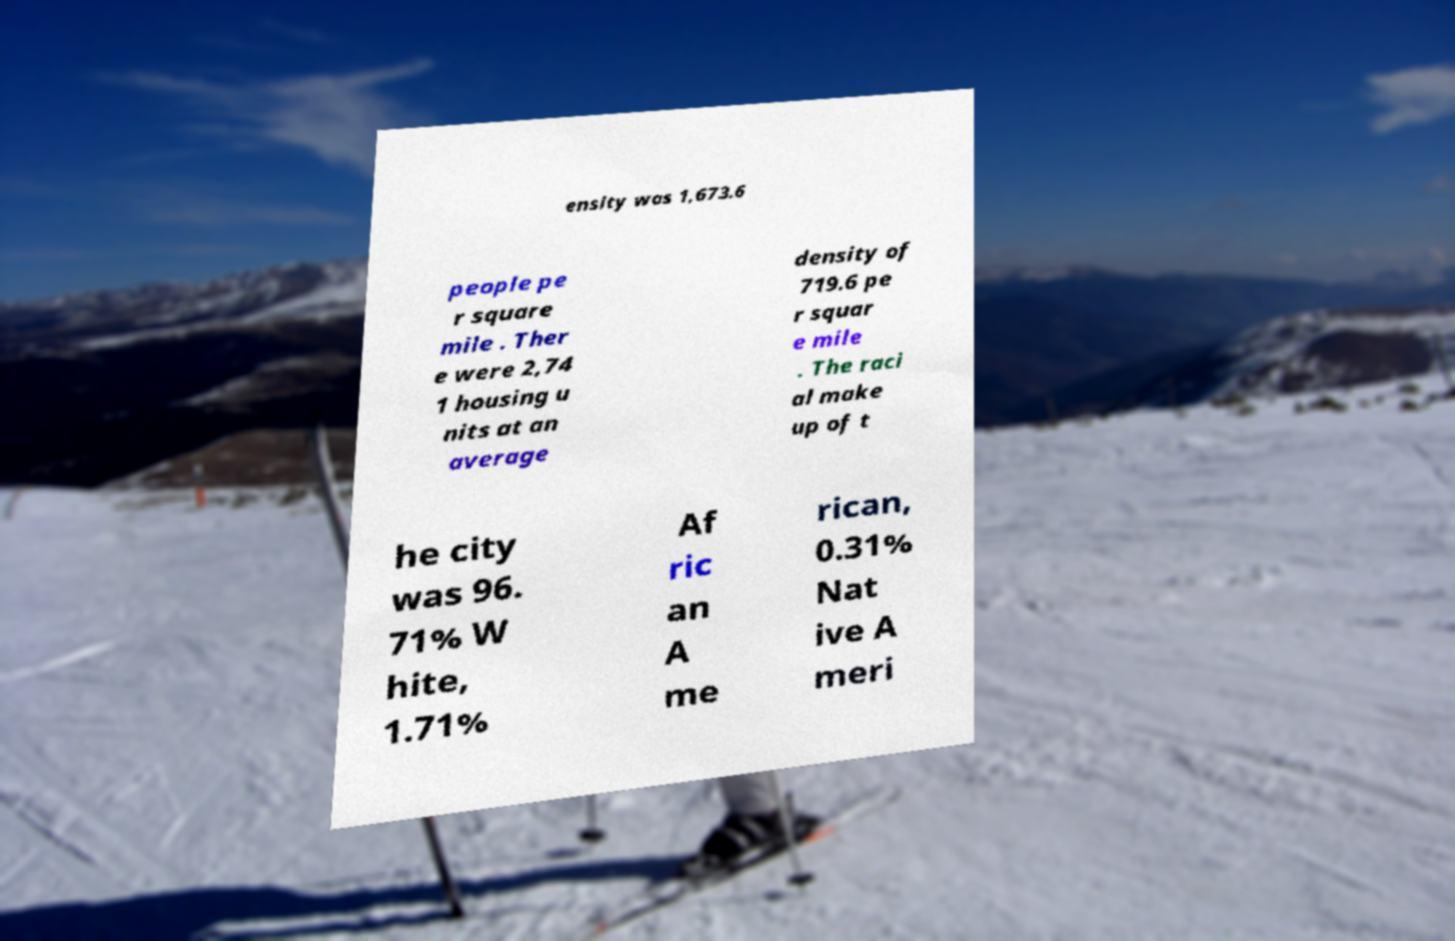There's text embedded in this image that I need extracted. Can you transcribe it verbatim? ensity was 1,673.6 people pe r square mile . Ther e were 2,74 1 housing u nits at an average density of 719.6 pe r squar e mile . The raci al make up of t he city was 96. 71% W hite, 1.71% Af ric an A me rican, 0.31% Nat ive A meri 